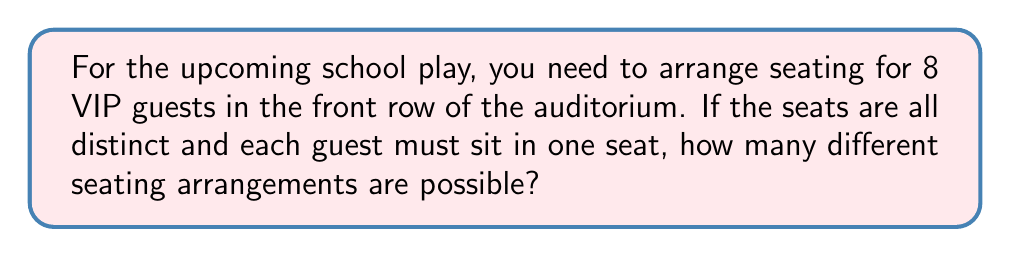Give your solution to this math problem. Let's approach this step-by-step:

1) This is a permutation problem. We are arranging 8 distinct people in 8 distinct seats.

2) For the first seat, we have 8 choices of who can sit there.

3) After the first person is seated, we have 7 choices for the second seat.

4) For the third seat, we have 6 choices, and so on.

5) This continues until we reach the last seat, where we only have 1 choice left.

6) Mathematically, this is represented as:

   $$8 \times 7 \times 6 \times 5 \times 4 \times 3 \times 2 \times 1$$

7) This is also known as 8 factorial, written as $8!$

8) We can calculate this:
   $$8! = 8 \times 7 \times 6 \times 5 \times 4 \times 3 \times 2 \times 1 = 40,320$$

Therefore, there are 40,320 different possible seating arrangements.
Answer: $40,320$ 